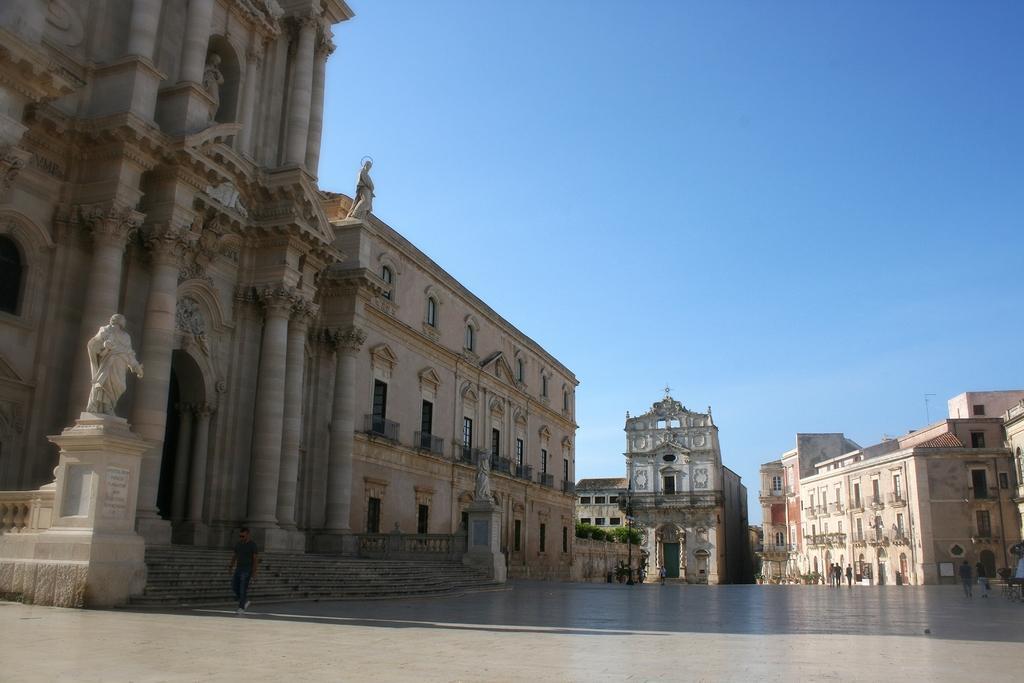How would you summarize this image in a sentence or two? In this image I can see number of buildings, few sculptures and on the right side of this image I can see number of people. In the background I can see bushes and the sky. 